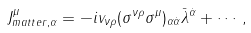Convert formula to latex. <formula><loc_0><loc_0><loc_500><loc_500>J _ { m a t t e r , \alpha } ^ { \mu } = - i v _ { \nu \rho } ( \sigma ^ { \nu \rho } \sigma ^ { \mu } ) _ { \alpha \dot { \alpha } } \bar { \lambda } ^ { \dot { \alpha } } + \cdots ,</formula> 